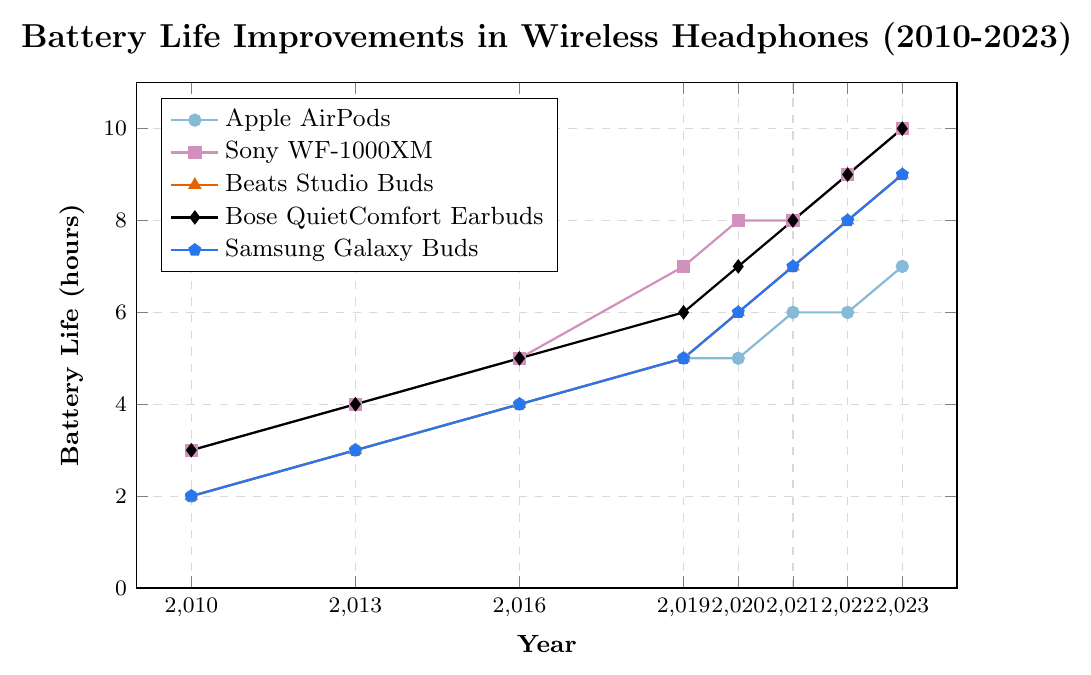How has the battery life of Apple AirPods changed from 2010 to 2023? According to the figure, Apple AirPods' battery life increased from 2 hours in 2010 to 7 hours in 2023.
Answer: It increased by 5 hours In what year did the Bose QuietComfort Earbuds surpass a 7-hour battery life? The figure shows that Bose QuietComfort Earbuds' battery life was 8 hours in 2021.
Answer: In 2021 Which brand showed the largest increase in battery life between 2010 and 2023? The figure indicates that Sony WF-1000XM's battery life increased from 3 hours in 2010 to 10 hours in 2023, an increase of 7 hours.
Answer: Sony WF-1000XM What is the average battery life of Samsung Galaxy Buds from 2010 to 2023? Calculating the average battery life: (2 + 3 + 4 + 5 + 6 + 7 + 8 + 9) / 8 = 5.5 hours.
Answer: 5.5 hours Compare the battery life of Beats Studio Buds and Bose QuietComfort Earbuds in 2023. Which one has a higher battery life, and by how much? In 2023, Beats Studio Buds have 9 hours, and Bose QuietComfort Earbuds have 10 hours. The Bose QuietComfort Earbuds have 1 hour more.
Answer: Bose QuietComfort Earbuds, by 1 hour Identify the year when all the brands first achieved a battery life of 5 hours or more. The figure shows that all brands had at least 5 hours of battery life in 2019.
Answer: 2019 How much did the battery life of Beats Studio Buds increase from 2019 to 2023? The figure shows that the battery life of Beats Studio Buds increased from 5 hours in 2019 to 9 hours in 2023, an increase of 4 hours.
Answer: 4 hours Which brand had the least battery life improvement from 2010 to 2019? Calculating the battery life improvement: Apple AirPods increased by 3 hours, Sony WF-1000XM by 4 hours, Beats Studio Buds by 3 hours, Bose QuietComfort Earbuds by 3 hours, Samsung Galaxy Buds by 3 hours. The least improvement is seen in Apple AirPods, Beats Studio Buds, Bose QuietComfort Earbuds, and Samsung Galaxy Buds, each with 3 hours.
Answer: Apple AirPods, Beats Studio Buds, Bose QuietComfort Earbuds, and Samsung Galaxy Buds (each had 3 hours improvement) What is the combined battery life of all brands in the year 2023? Summing the battery life: Apple AirPods (7) + Sony WF-1000XM (10) + Beats Studio Buds (9) + Bose QuietComfort Earbuds (10) + Samsung Galaxy Buds (9) = 45 hours.
Answer: 45 hours In which year did the battery life of Samsung Galaxy Buds equal that of Apple AirPods? Both Samsung Galaxy Buds and Apple AirPods had equal battery life of 4 hours in 2016.
Answer: 2016 